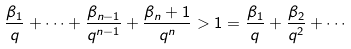<formula> <loc_0><loc_0><loc_500><loc_500>\frac { \beta _ { 1 } } { q } + \cdots + \frac { \beta _ { n - 1 } } { q ^ { n - 1 } } + \frac { \beta _ { n } + 1 } { q ^ { n } } > 1 = \frac { \beta _ { 1 } } { q } + \frac { \beta _ { 2 } } { q ^ { 2 } } + \cdots</formula> 